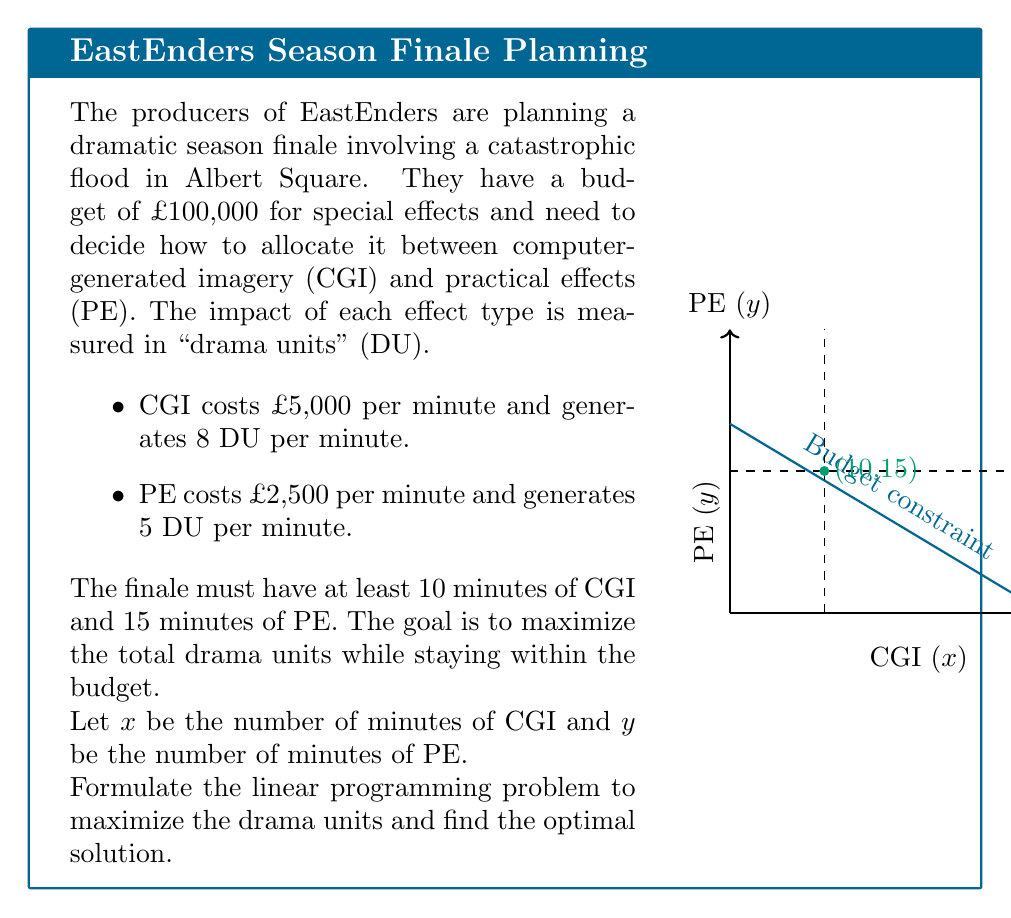Give your solution to this math problem. Let's approach this step-by-step:

1) First, let's define our objective function. We want to maximize the total drama units:
   Maximize: $z = 8x + 5y$

2) Now, let's list our constraints:
   a) Budget constraint: $5000x + 2500y \leq 100000$
   b) Minimum CGI requirement: $x \geq 10$
   c) Minimum PE requirement: $y \geq 15$
   d) Non-negativity: $x \geq 0, y \geq 0$

3) Simplify the budget constraint:
   $5000x + 2500y \leq 100000$
   $2x + y \leq 40$

4) Our linear programming problem is now:
   Maximize: $z = 8x + 5y$
   Subject to:
   $2x + y \leq 40$
   $x \geq 10$
   $y \geq 15$
   $x, y \geq 0$

5) To solve this, we can use the corner point method. The feasible region is bounded by the lines:
   $2x + y = 40$ (budget constraint)
   $x = 10$ (minimum CGI)
   $y = 15$ (minimum PE)

6) The corner points are:
   (10, 15), (10, 20), (12.5, 15)

7) Evaluating the objective function at these points:
   At (10, 15): $z = 8(10) + 5(15) = 155$
   At (10, 20): $z = 8(10) + 5(20) = 180$
   At (12.5, 15): $z = 8(12.5) + 5(15) = 175$

8) The maximum value occurs at (10, 20), which means 10 minutes of CGI and 20 minutes of PE.
Answer: 10 minutes CGI, 20 minutes PE; 180 drama units 